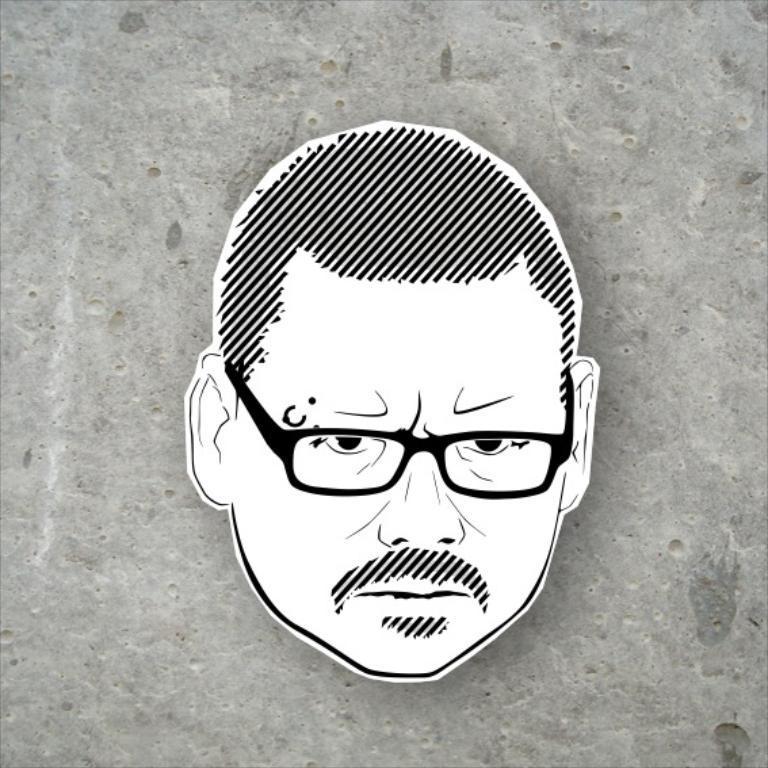How would you summarize this image in a sentence or two? In the given picture, I can see a person face wearing specs which is drawn and behind this i can see a wall. 